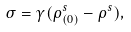Convert formula to latex. <formula><loc_0><loc_0><loc_500><loc_500>\sigma = \gamma ( \rho ^ { s } _ { ( 0 ) } - \rho ^ { s } ) ,</formula> 